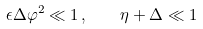<formula> <loc_0><loc_0><loc_500><loc_500>\epsilon \Delta \varphi ^ { 2 } \ll 1 \, , \quad \eta + \Delta \ll 1</formula> 